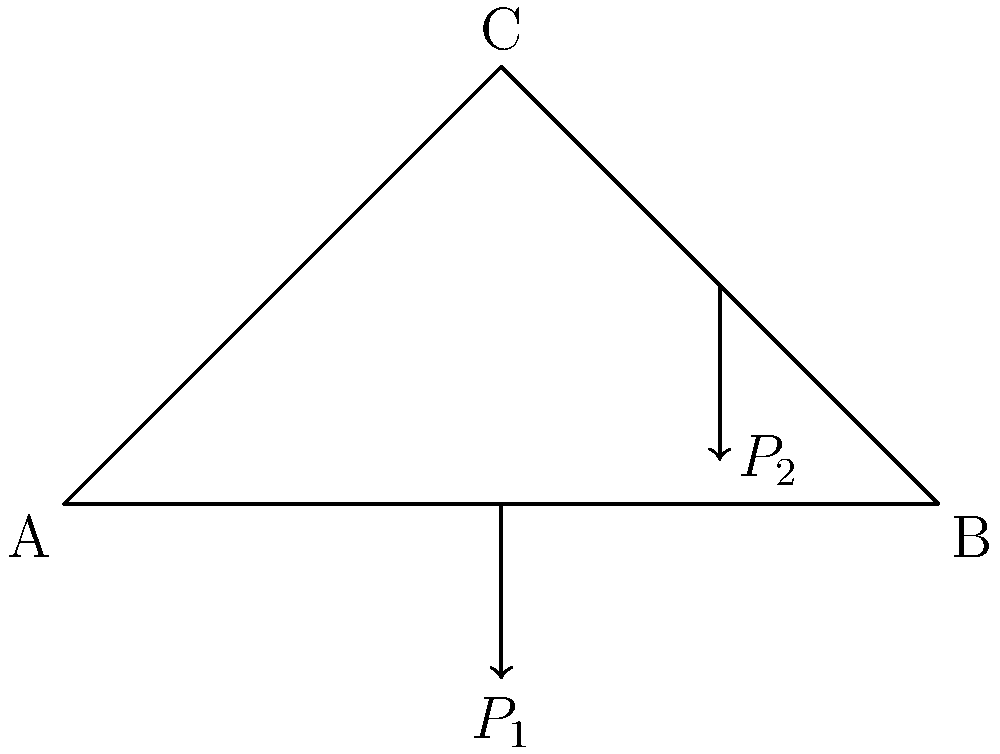Given the simple truss structure shown in the diagram, where $P_1$ is a vertical load applied at the midpoint of member AB and $P_2$ is a vertical load applied at the midpoint of member BC, determine which member of the truss experiences the highest axial stress. Assume all members have the same cross-sectional area. To determine which member experiences the highest axial stress, we need to analyze the force distribution in the truss:

1. First, calculate the reactions at supports A and B:
   $$R_A + R_B = P_1 + P_2$$
   $$R_A \cdot 100 = P_2 \cdot 75 + P_1 \cdot 50$$

2. Solve for member forces using the method of joints or method of sections.

3. For member AB:
   The axial force will be a combination of the horizontal component of the force in AC and the vertical load $P_1$.

4. For member BC:
   The axial force will be a combination of the horizontal component of the force in AC and the vertical load $P_2$.

5. For member AC:
   This member will experience only axial tension or compression, depending on the magnitudes of $P_1$ and $P_2$.

6. Compare the magnitudes of the axial forces in each member.

7. Since stress is force divided by area, and all members have the same cross-sectional area, the member with the highest axial force will experience the highest stress.

8. Generally, in this configuration, member AC is likely to experience the highest axial stress because it carries components of both applied loads $P_1$ and $P_2$.
Answer: Member AC likely experiences the highest axial stress. 